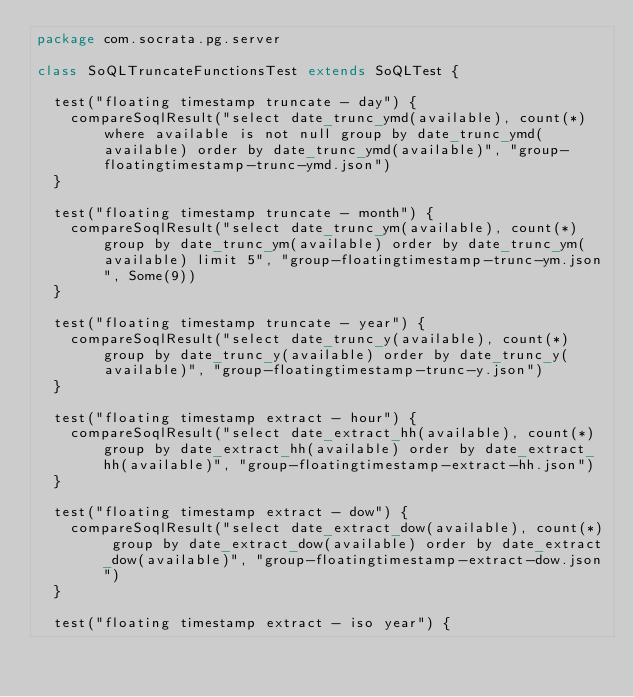<code> <loc_0><loc_0><loc_500><loc_500><_Scala_>package com.socrata.pg.server

class SoQLTruncateFunctionsTest extends SoQLTest {

  test("floating timestamp truncate - day") {
    compareSoqlResult("select date_trunc_ymd(available), count(*) where available is not null group by date_trunc_ymd(available) order by date_trunc_ymd(available)", "group-floatingtimestamp-trunc-ymd.json")
  }

  test("floating timestamp truncate - month") {
    compareSoqlResult("select date_trunc_ym(available), count(*) group by date_trunc_ym(available) order by date_trunc_ym(available) limit 5", "group-floatingtimestamp-trunc-ym.json", Some(9))
  }

  test("floating timestamp truncate - year") {
    compareSoqlResult("select date_trunc_y(available), count(*) group by date_trunc_y(available) order by date_trunc_y(available)", "group-floatingtimestamp-trunc-y.json")
  }

  test("floating timestamp extract - hour") {
    compareSoqlResult("select date_extract_hh(available), count(*) group by date_extract_hh(available) order by date_extract_hh(available)", "group-floatingtimestamp-extract-hh.json")
  }

  test("floating timestamp extract - dow") {
    compareSoqlResult("select date_extract_dow(available), count(*) group by date_extract_dow(available) order by date_extract_dow(available)", "group-floatingtimestamp-extract-dow.json")
  }

  test("floating timestamp extract - iso year") {</code> 